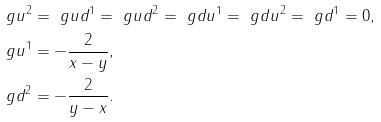<formula> <loc_0><loc_0><loc_500><loc_500>\ g u ^ { 2 } & = \ g u d ^ { 1 } = \ g u d ^ { 2 } = \ g d u ^ { 1 } = \ g d u ^ { 2 } = \ g d ^ { 1 } = 0 , \\ \ g u ^ { 1 } & = - \frac { 2 } { x - y } , \\ \ g d ^ { 2 } & = - \frac { 2 } { y - x } .</formula> 